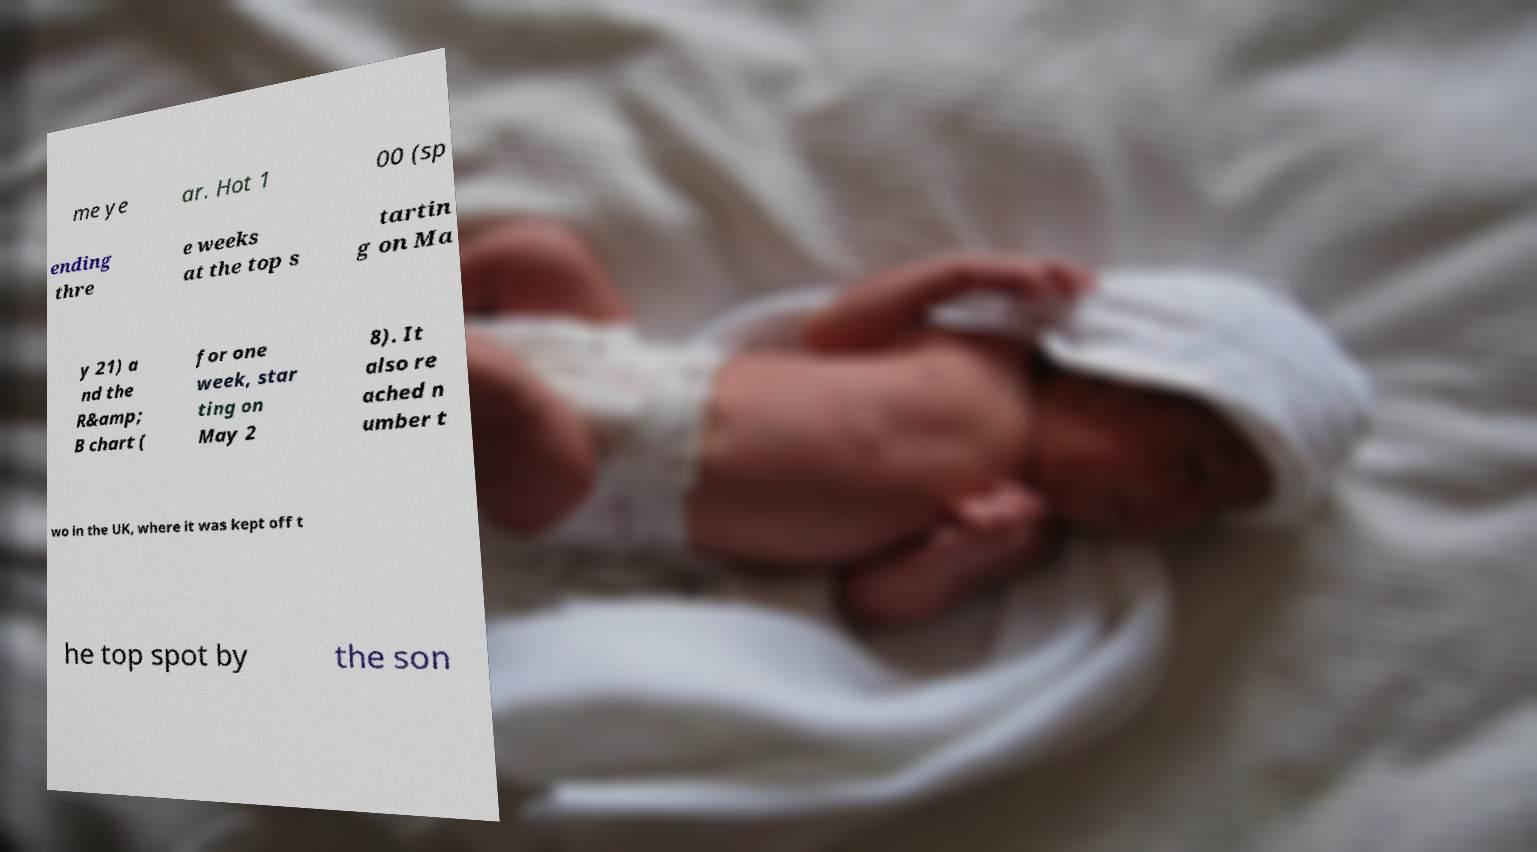Please read and relay the text visible in this image. What does it say? me ye ar. Hot 1 00 (sp ending thre e weeks at the top s tartin g on Ma y 21) a nd the R&amp; B chart ( for one week, star ting on May 2 8). It also re ached n umber t wo in the UK, where it was kept off t he top spot by the son 